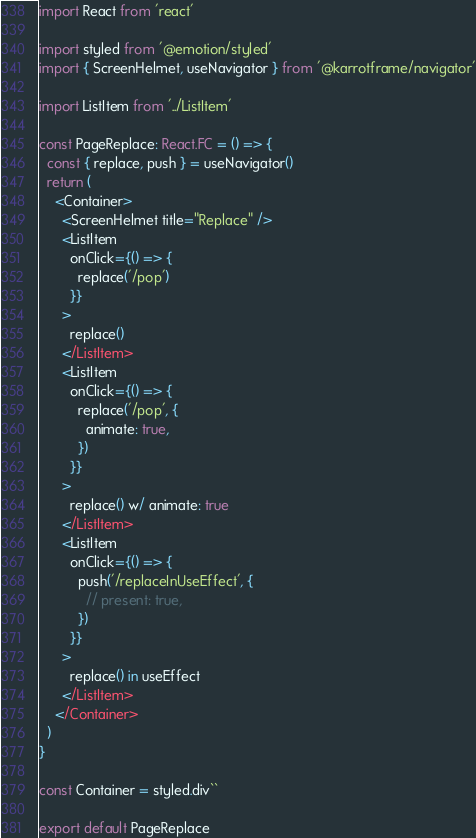Convert code to text. <code><loc_0><loc_0><loc_500><loc_500><_TypeScript_>import React from 'react'

import styled from '@emotion/styled'
import { ScreenHelmet, useNavigator } from '@karrotframe/navigator'

import ListItem from '../ListItem'

const PageReplace: React.FC = () => {
  const { replace, push } = useNavigator()
  return (
    <Container>
      <ScreenHelmet title="Replace" />
      <ListItem
        onClick={() => {
          replace('/pop')
        }}
      >
        replace()
      </ListItem>
      <ListItem
        onClick={() => {
          replace('/pop', {
            animate: true,
          })
        }}
      >
        replace() w/ animate: true
      </ListItem>
      <ListItem
        onClick={() => {
          push('/replaceInUseEffect', {
            // present: true,
          })
        }}
      >
        replace() in useEffect
      </ListItem>
    </Container>
  )
}

const Container = styled.div``

export default PageReplace
</code> 